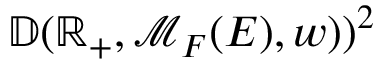Convert formula to latex. <formula><loc_0><loc_0><loc_500><loc_500>\mathbb { D } ( \mathbb { R } _ { + } , \mathcal { M } _ { F } ( E ) , w ) ) ^ { 2 }</formula> 